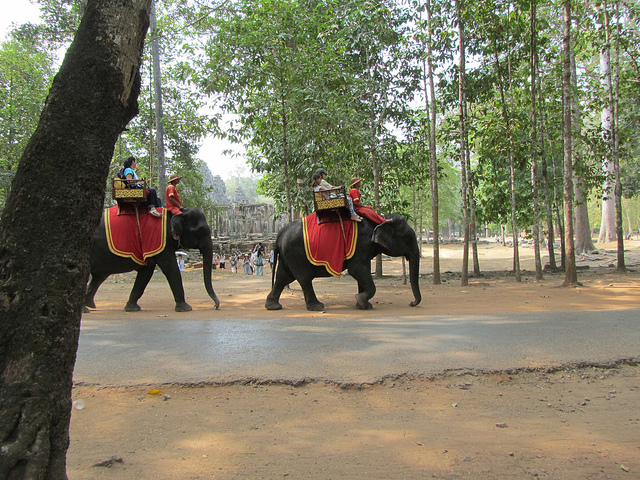How many elephants are visible? 2 